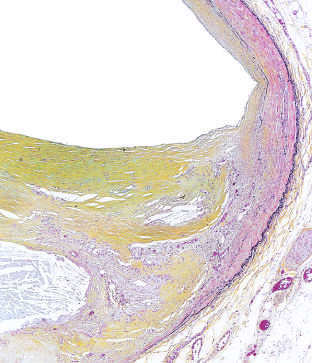re the internal and external elastic membranes attenuated?
Answer the question using a single word or phrase. Yes 